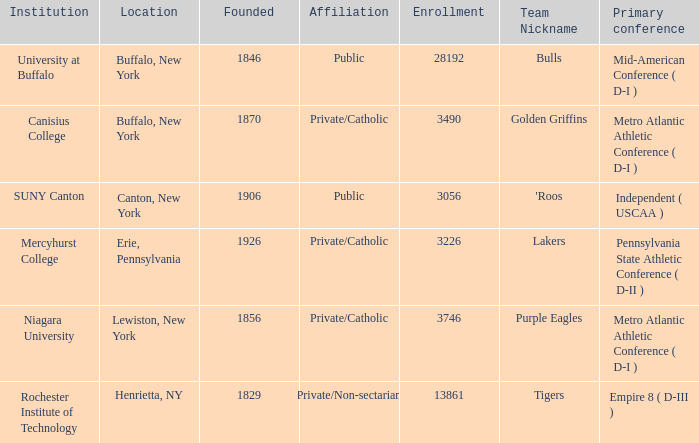What is the association of erie, pennsylvania? Private/Catholic. 